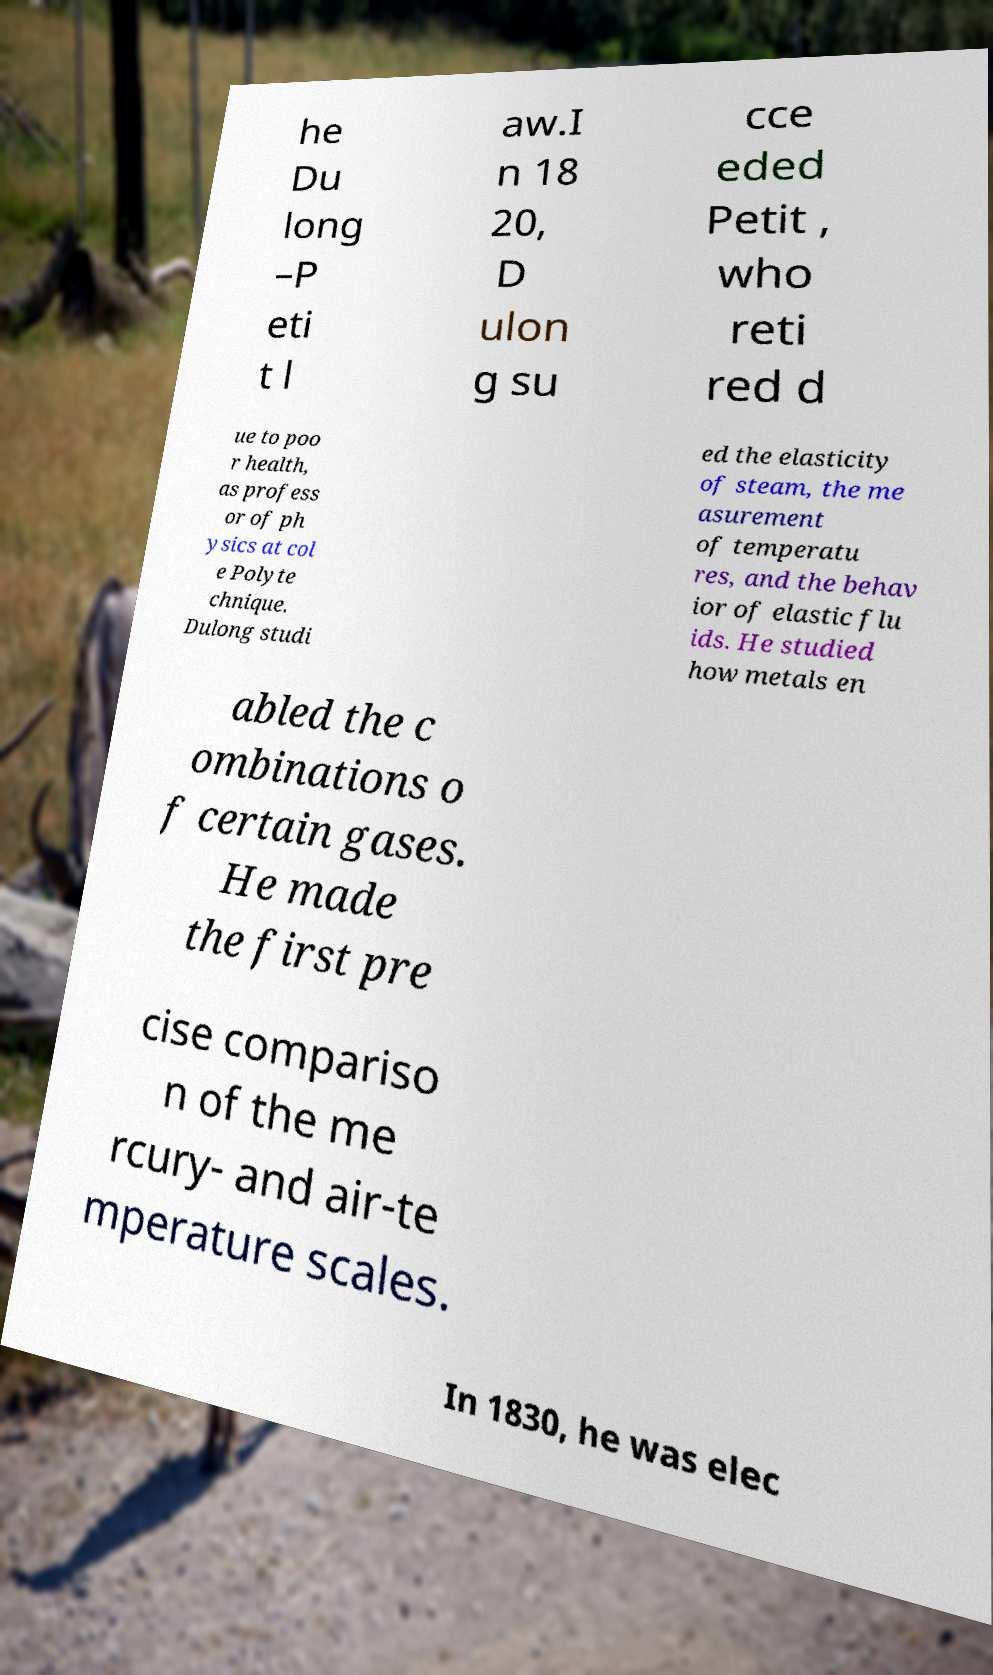Can you accurately transcribe the text from the provided image for me? he Du long –P eti t l aw.I n 18 20, D ulon g su cce eded Petit , who reti red d ue to poo r health, as profess or of ph ysics at col e Polyte chnique. Dulong studi ed the elasticity of steam, the me asurement of temperatu res, and the behav ior of elastic flu ids. He studied how metals en abled the c ombinations o f certain gases. He made the first pre cise compariso n of the me rcury- and air-te mperature scales. In 1830, he was elec 